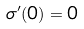Convert formula to latex. <formula><loc_0><loc_0><loc_500><loc_500>\sigma ^ { \prime } ( 0 ) = 0</formula> 